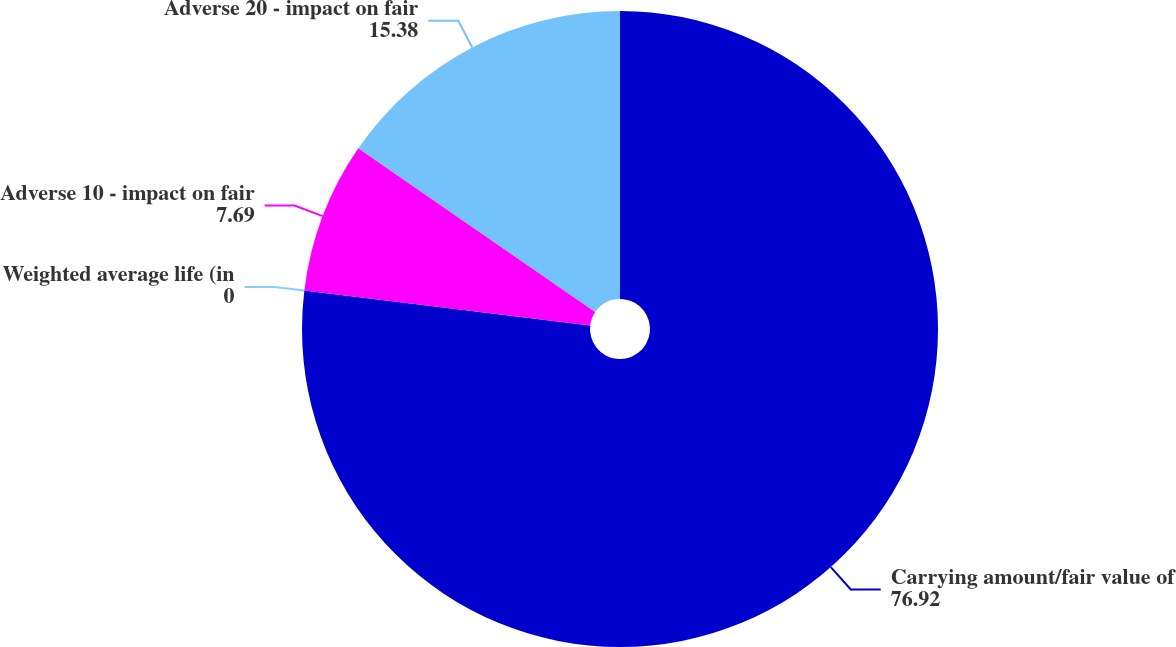<chart> <loc_0><loc_0><loc_500><loc_500><pie_chart><fcel>Carrying amount/fair value of<fcel>Weighted average life (in<fcel>Adverse 10 - impact on fair<fcel>Adverse 20 - impact on fair<nl><fcel>76.92%<fcel>0.0%<fcel>7.69%<fcel>15.38%<nl></chart> 